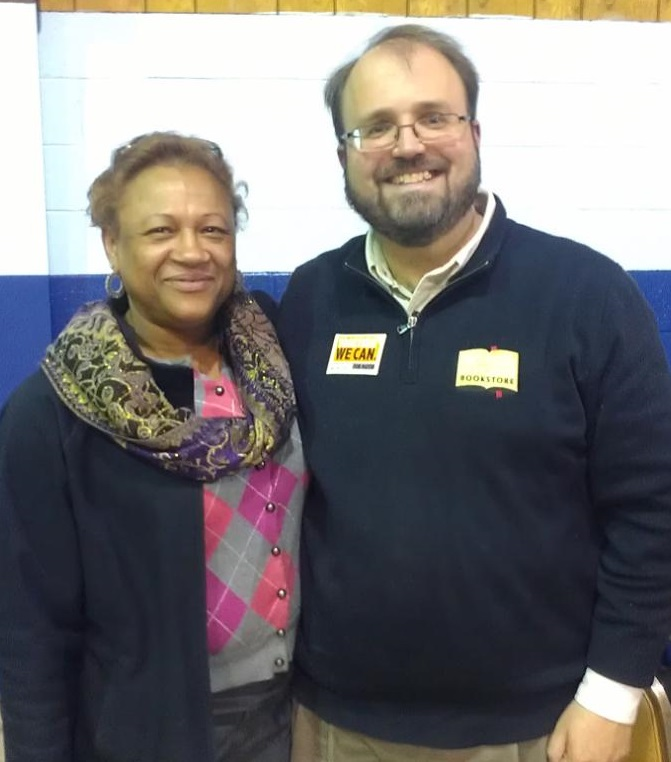In the background, there is a street sign with a unique symbol. Considering the activities of people and the types of shops present, what might this symbol signify about this area of the city? The symbol on the street sign, in conjunction with the diverse shops present such as a bookstore and a cafe, and the activities of people including tourists taking photos and a street artist sketching, suggests that this area of the city could be a vibrant cultural or artistic hub. This district may be known for its creative energy, rich cultural significance, and appeal to both locals and tourists who have an interest in the arts, literature, and leisurely pursuits. Such an area often provides a warm and welcoming environment for creativity to flourish, making it an attractive destination for various forms of artistic expression. 